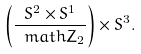Convert formula to latex. <formula><loc_0><loc_0><loc_500><loc_500>\left ( \frac { S ^ { 2 } \times S ^ { 1 } } { \ m a t h Z _ { 2 } } \right ) \times S ^ { 3 } .</formula> 